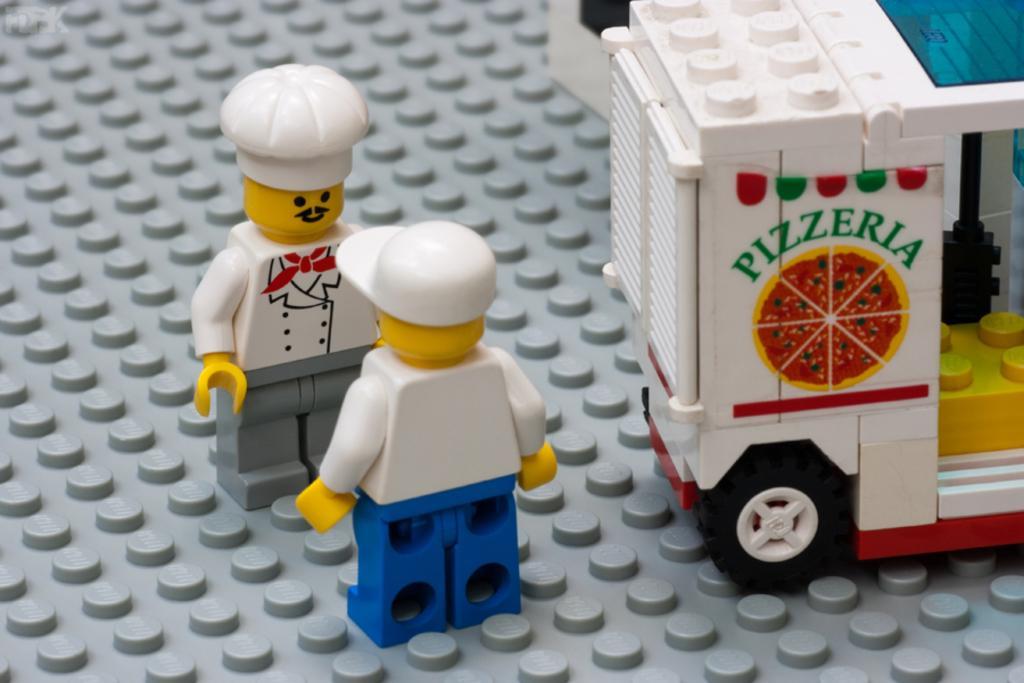In one or two sentences, can you explain what this image depicts? In this picture there are two toys in the center of the image and there is a toy vehicle on the right side of the image. 